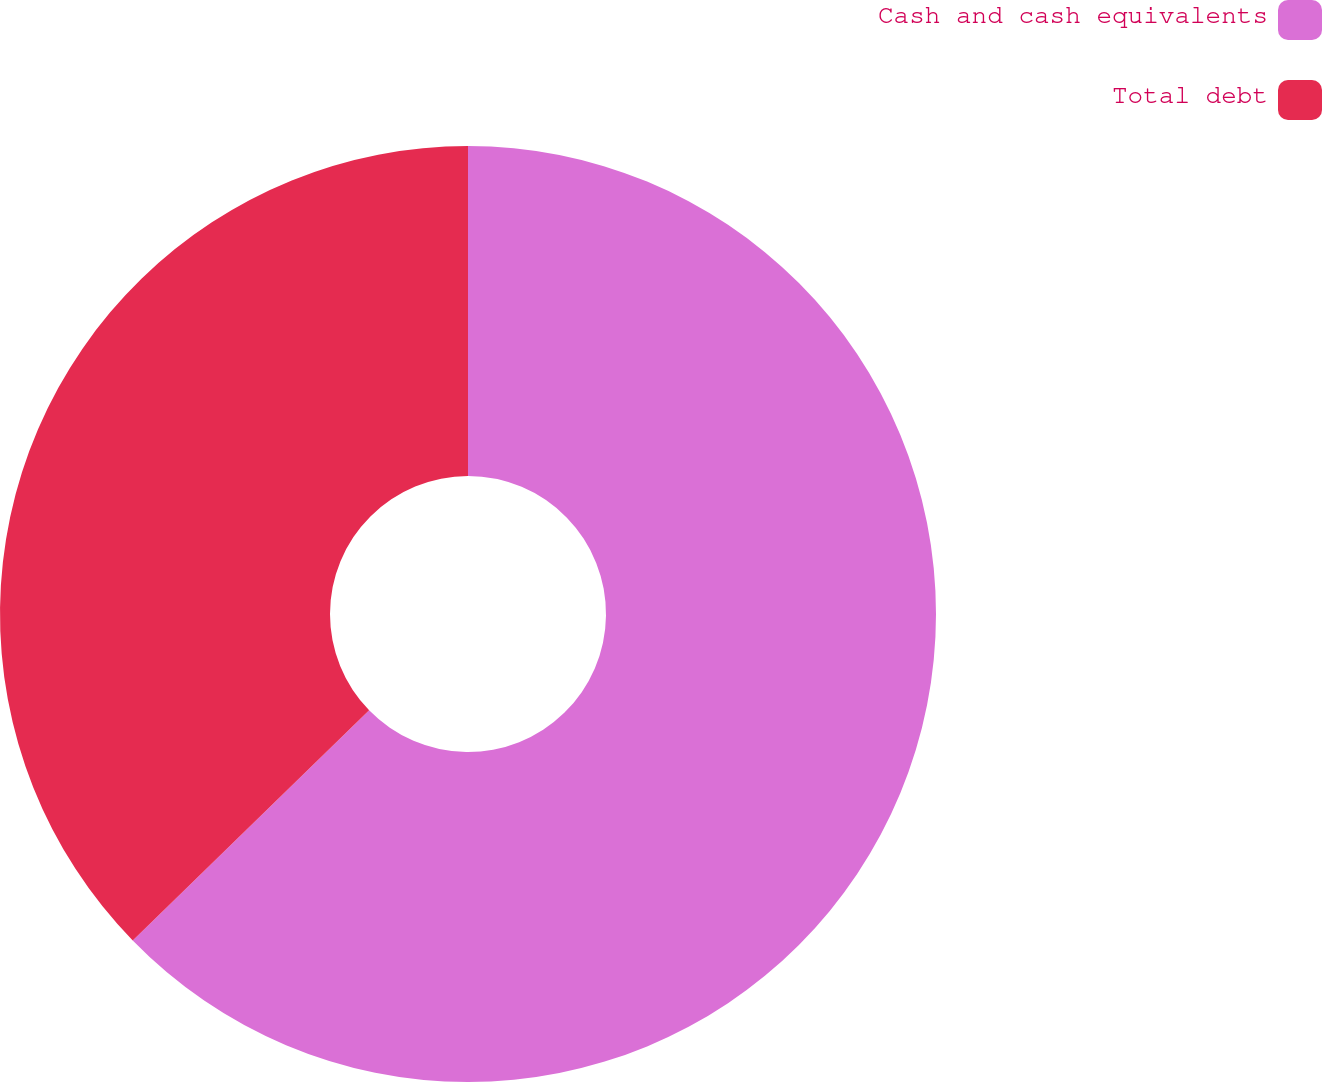Convert chart. <chart><loc_0><loc_0><loc_500><loc_500><pie_chart><fcel>Cash and cash equivalents<fcel>Total debt<nl><fcel>62.71%<fcel>37.29%<nl></chart> 